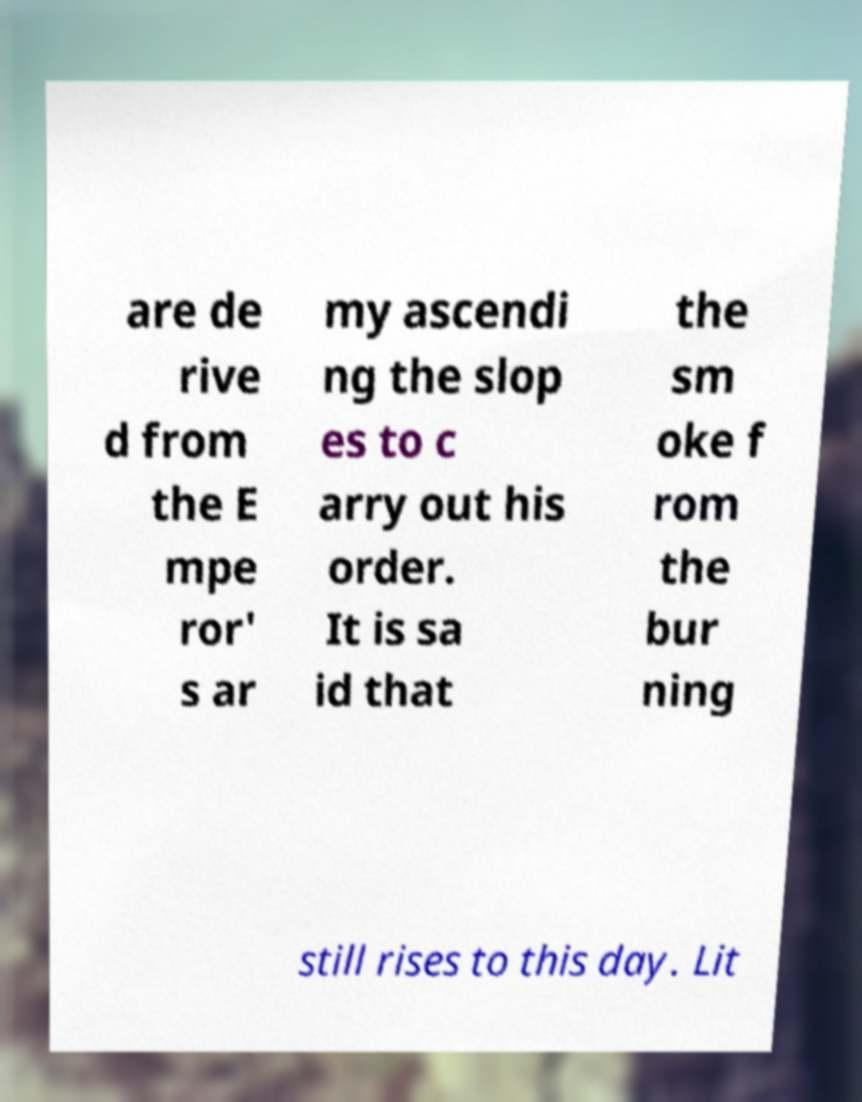Can you read and provide the text displayed in the image?This photo seems to have some interesting text. Can you extract and type it out for me? are de rive d from the E mpe ror' s ar my ascendi ng the slop es to c arry out his order. It is sa id that the sm oke f rom the bur ning still rises to this day. Lit 